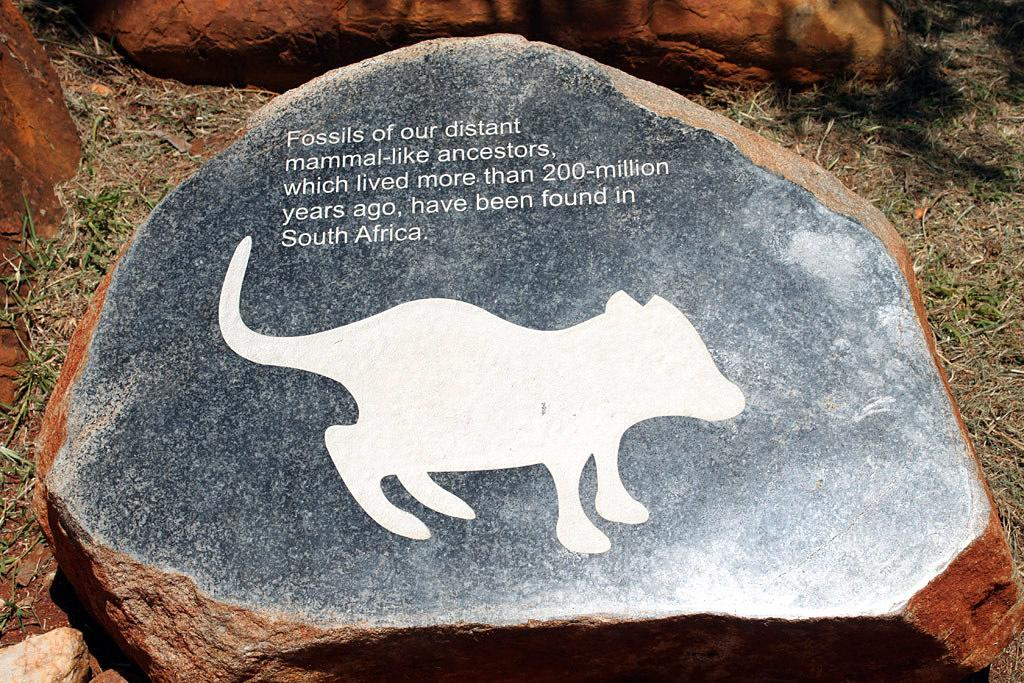What is the main object in the image? There is a stone in the image. What is depicted on the stone? The stone has a picture of an animal on it. Is there any text on the stone? Yes, there is writing on the stone. What type of natural environment can be seen in the image? There is grass visible in the image. How many stones are present in the image? There are other stones in the image. What type of iron is being used to play the instrument in the image? There is no iron or instrument present in the image; it features a stone with a picture of an animal and writing. Can you tell me how many turkeys are depicted on the stone? There is no turkey depicted on the stone; it has a picture of an animal, but it is not specified as a turkey. 